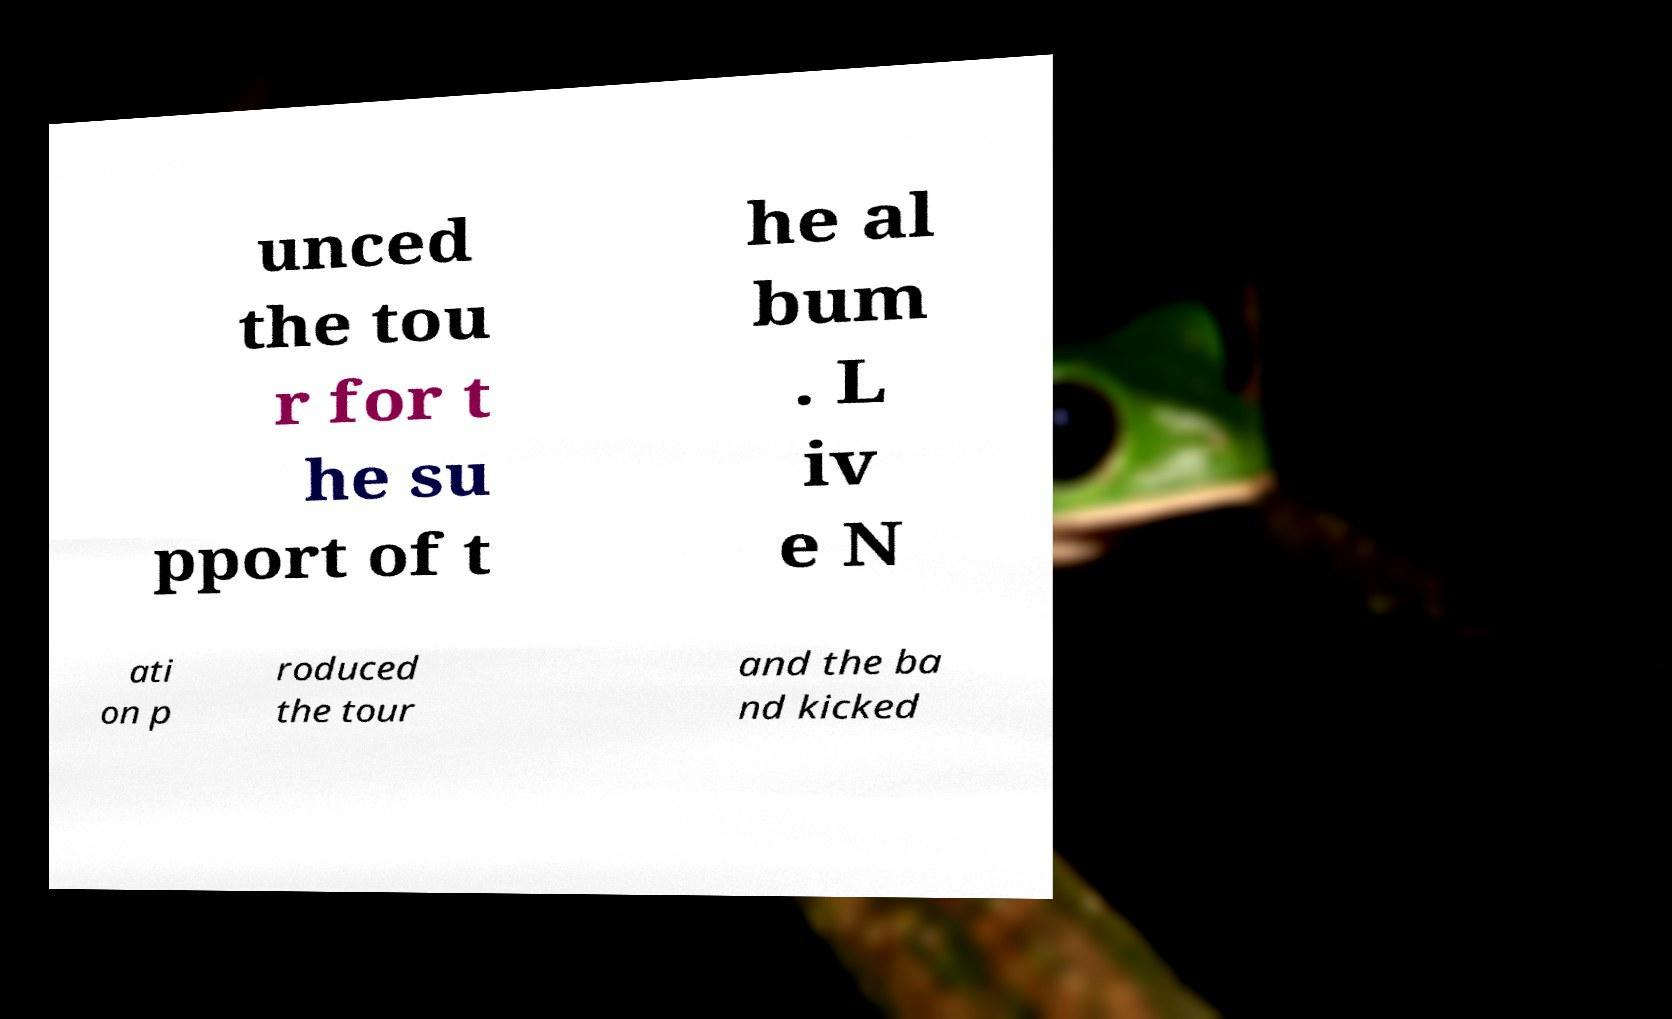Please identify and transcribe the text found in this image. unced the tou r for t he su pport of t he al bum . L iv e N ati on p roduced the tour and the ba nd kicked 